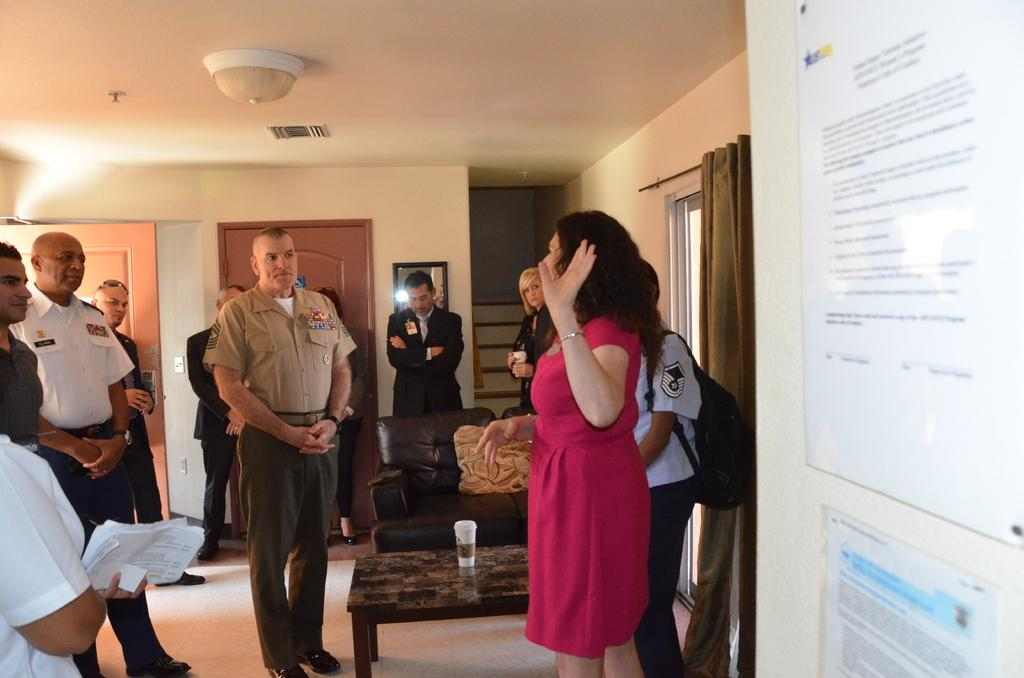Who or what can be seen in the image? There are people in the image. What is on the table in the image? There is an object on the table. What type of furniture is present in the image? There is a sofa in the image. What architectural features can be seen in the background? There are doors visible in the background. What reflective surface is present in the background? There is a mirror in the background. What type of amusement can be seen in the image? There is no amusement present in the image; it is a scene with people, furniture, and architectural features. How many beds are visible in the image? There are no beds visible in the image. 